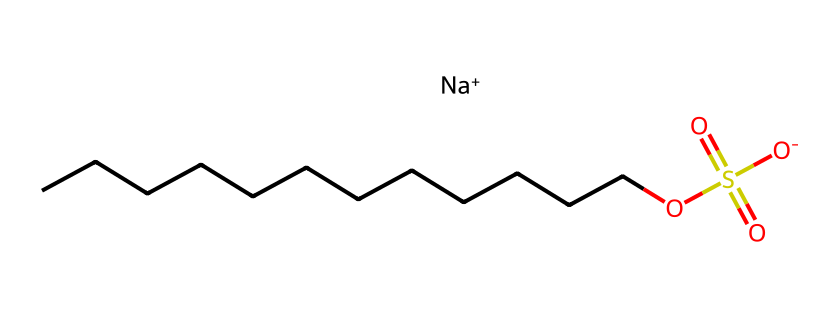How many carbon atoms are in sodium lauryl sulfate? The SMILES representation shows a continuous chain of carbon atoms (C) indicated by "CCCCCCCCCCCC". Counting these, there are 12 carbon atoms.
Answer: 12 What type of functional group is present in sodium lauryl sulfate? The "OS(=O)(=O)[O-]" part of the SMILES indicates the presence of a sulfate group (–SO4) that has oxygen atoms double-bonded and bonded to a sulfur atom. This characterizes it as a sulfonate functional group.
Answer: sulfonate How many oxygen atoms are included in sodium lauryl sulfate? In the sulfate part "OS(=O)(=O)[O-]", there are a total of 4 oxygen atoms (as indicated by the four occurrences of O). Thus, the answer is 4.
Answer: 4 Which part of the sodium lauryl sulfate molecule contributes to its surfactant properties? The hydrophobic carbon chain ("CCCCCCCCCCCC") and the hydrophilic sulfate group ("OS(=O)(=O)[O-]") together allow sodium lauryl sulfate to reduce surface tension, contributing to its surfactant properties.
Answer: both parts What is the charge of the sodium ion in sodium lauryl sulfate? The "Na+" in the SMILES indicates that the sodium ion carries a positive charge, which is essential for the compound's overall ionic character.
Answer: positive 